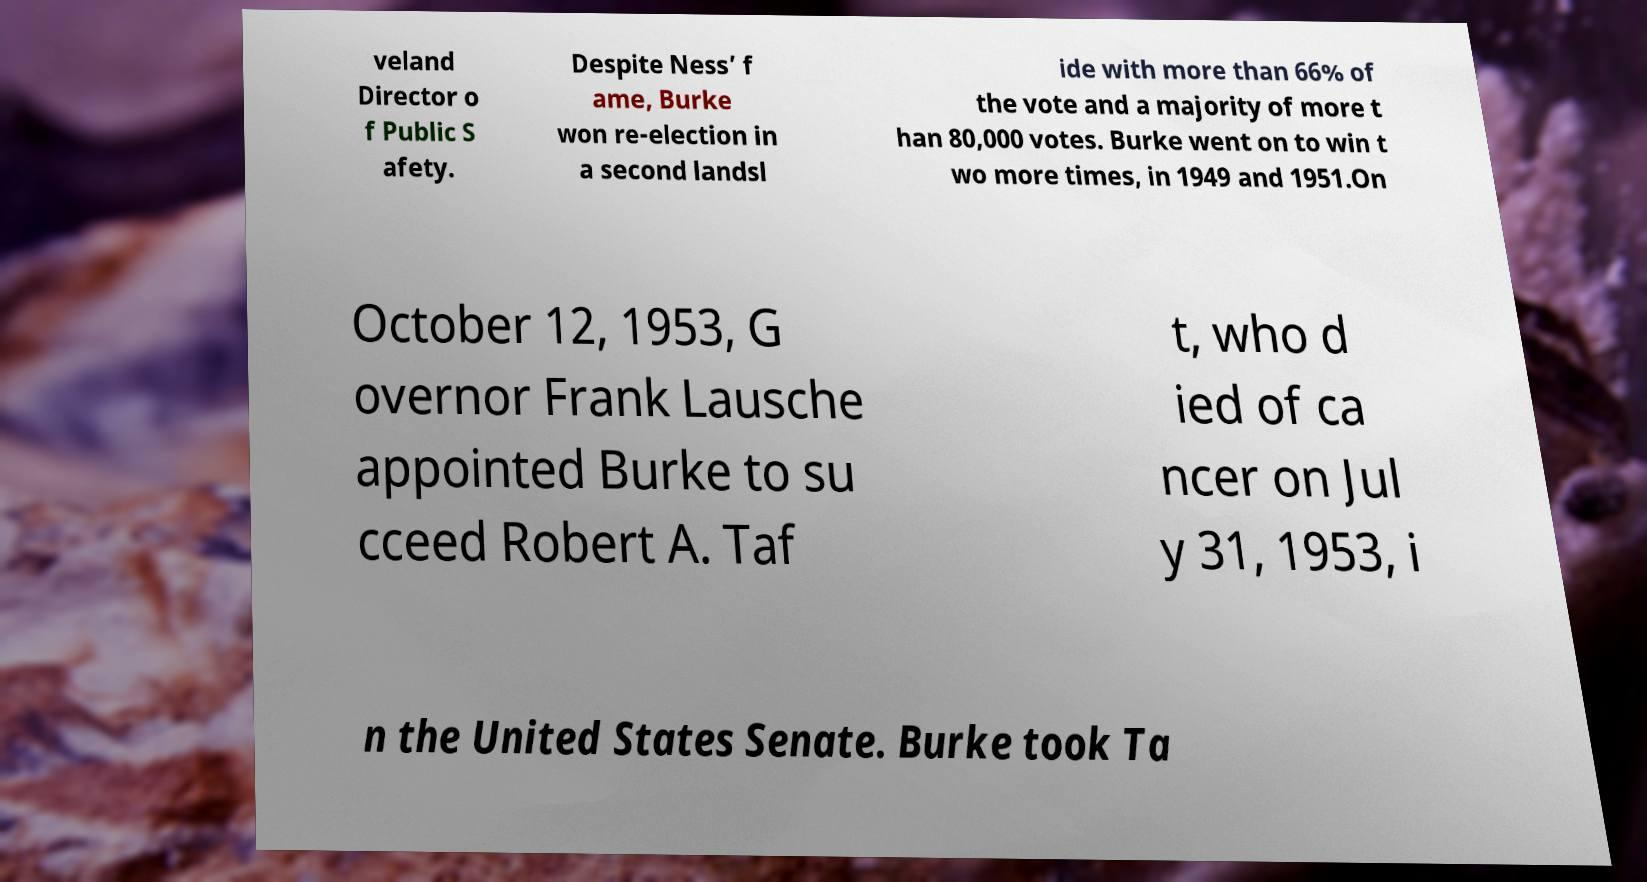Please read and relay the text visible in this image. What does it say? veland Director o f Public S afety. Despite Ness’ f ame, Burke won re-election in a second landsl ide with more than 66% of the vote and a majority of more t han 80,000 votes. Burke went on to win t wo more times, in 1949 and 1951.On October 12, 1953, G overnor Frank Lausche appointed Burke to su cceed Robert A. Taf t, who d ied of ca ncer on Jul y 31, 1953, i n the United States Senate. Burke took Ta 